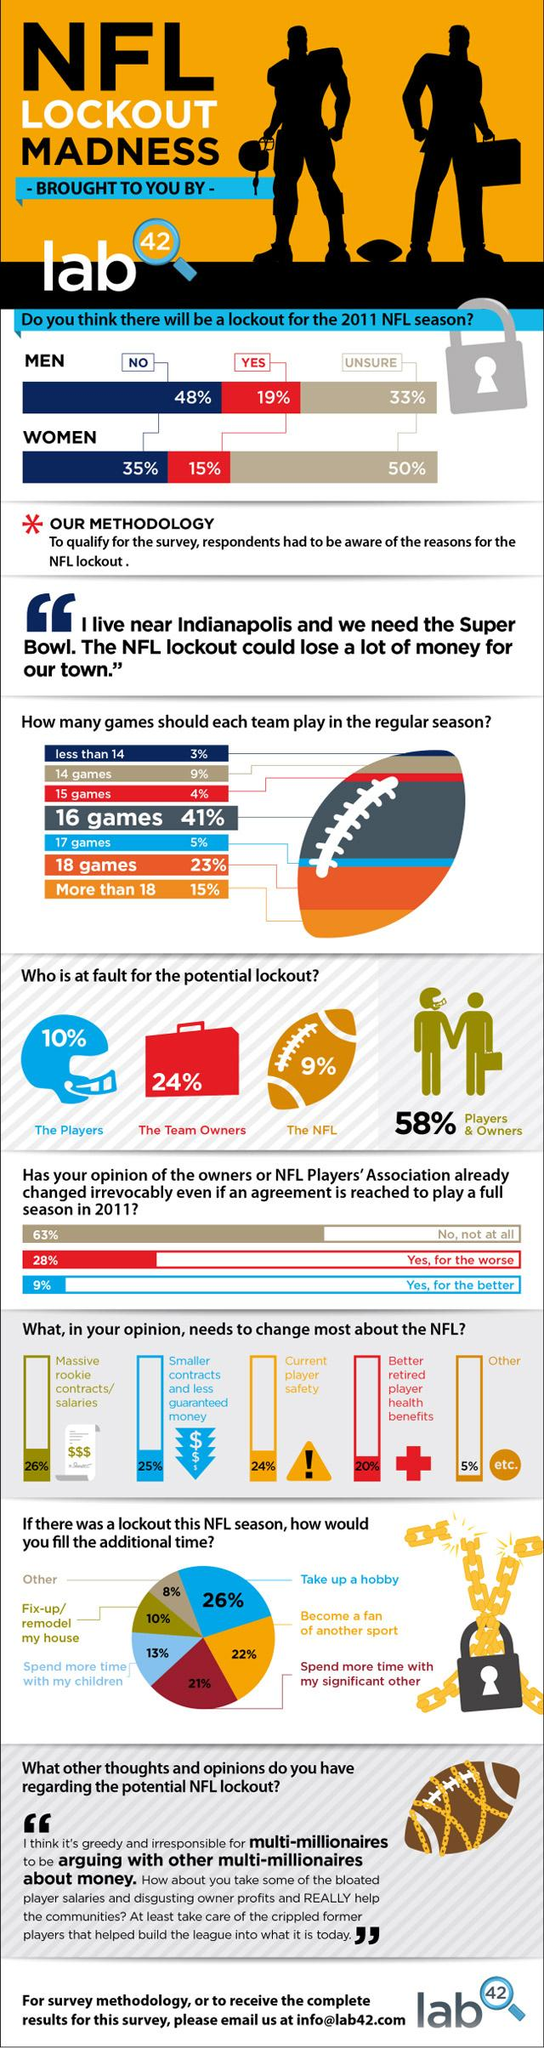Draw attention to some important aspects in this diagram. The majority of respondents to the survey believe that each NFL team should play 16 games during the regular season. According to the survey, 20% of respondents believed that there should be improved health benefits for retired NFL players. In the survey, 15% of respondents believe that each NFL team should play more than 18 games in the regular season. According to the survey, 24% of respondents believe that the fault of the team owners will lead to a lockout in the 2011 NFL season. According to the survey, the majority of respondents would take up a hobby in the event of an NFL lockout, indicating a strong interest in finding alternative activities during the season. 